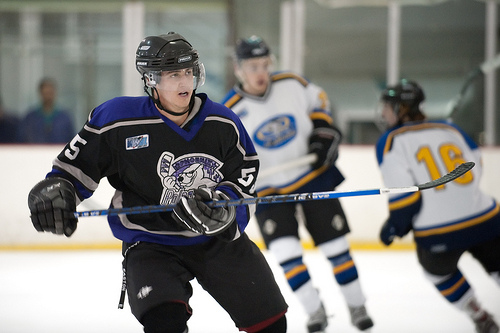<image>
Can you confirm if the helmet is on the man? No. The helmet is not positioned on the man. They may be near each other, but the helmet is not supported by or resting on top of the man. Where is the stick in relation to the man? Is it on the man? No. The stick is not positioned on the man. They may be near each other, but the stick is not supported by or resting on top of the man. 